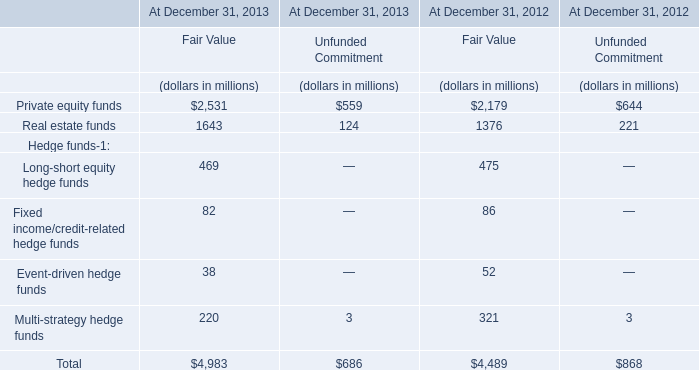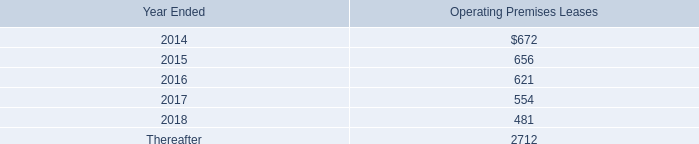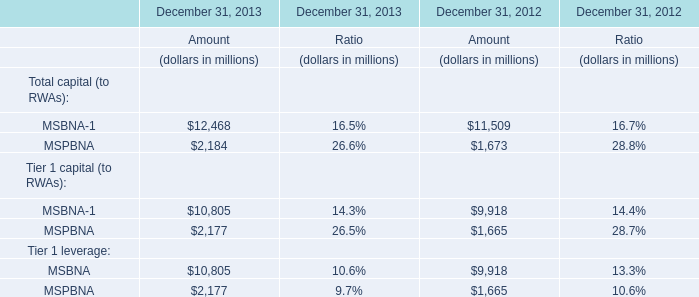What was the total amount of elements greater than 10000 in 2013? (in million) 
Computations: ((12468 + 10805) + 10805)
Answer: 34078.0. 